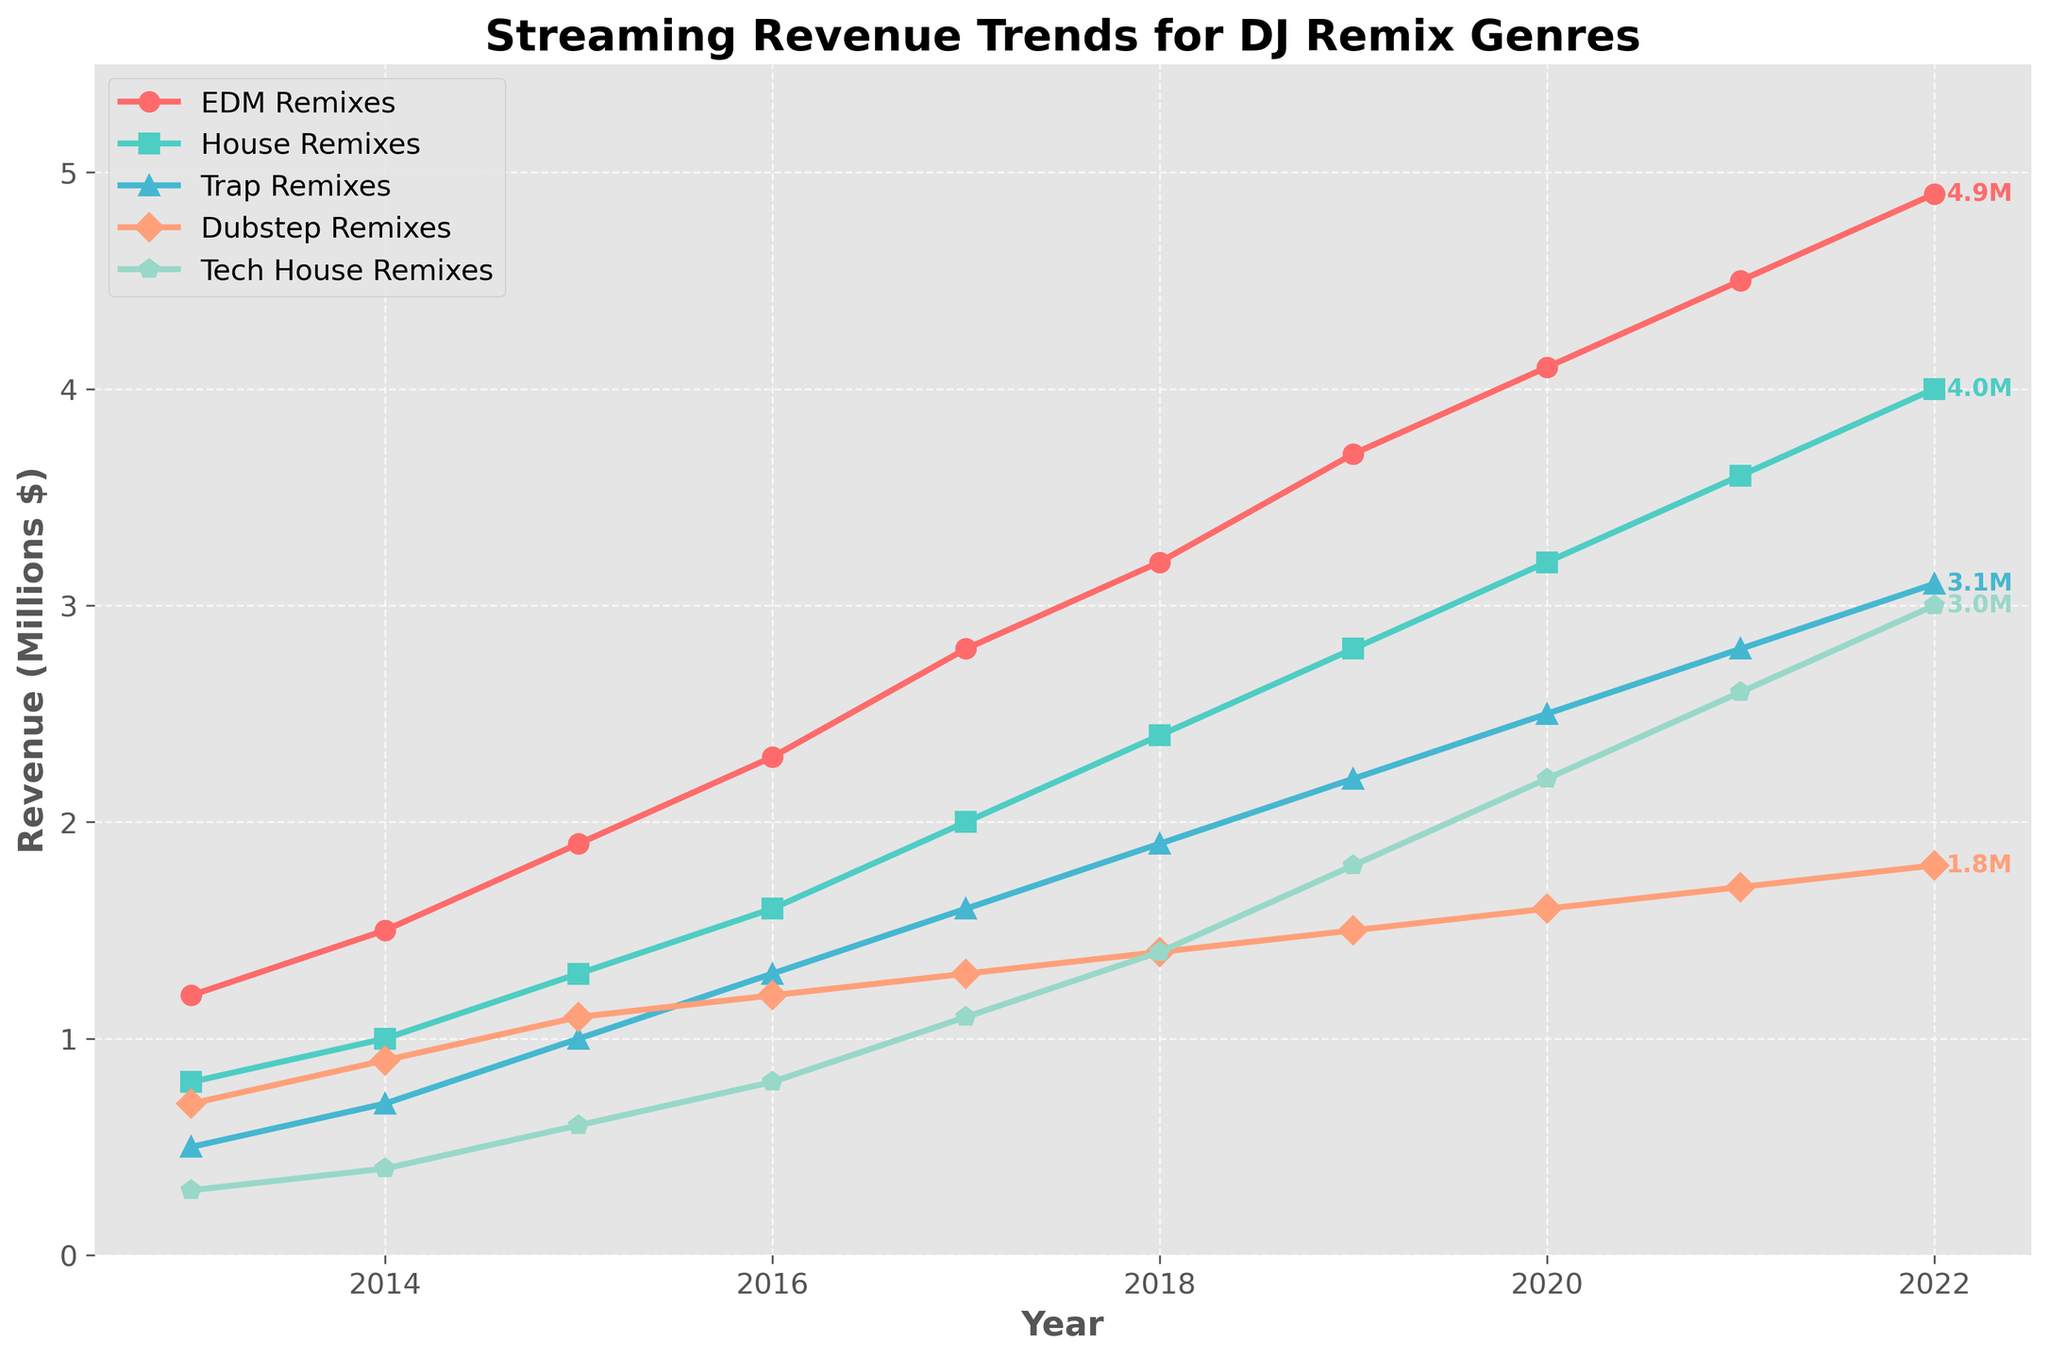What genres are included in the figure? The figure shows the streaming revenue trends for EDM Remixes, House Remixes, Trap Remixes, Dubstep Remixes, and Tech House Remixes.
Answer: EDM Remixes, House Remixes, Trap Remixes, Dubstep Remixes, Tech House Remixes Which remix genre had the highest streaming revenue in 2022? By looking at the endpoints of the lines for the year 2022, EDM Remixes had the highest value at 4.9 million dollars.
Answer: EDM Remixes How has the streaming revenue for House Remixes changed from 2013 to 2022? In 2013, the revenue for House Remixes was 0.8 million dollars. In 2022, it was 4.0 million dollars. So, the change is 4.0 - 0.8 = 3.2 million dollars.
Answer: Increased by 3.2 million dollars Which genre showed the most consistent growth over the decade? Comparing the trends across all genres, EDM Remixes show a steady and consistent upwards trajectory without significant dips.
Answer: EDM Remixes In which year did Dubstep Remixes experience the smallest revenue increase compared to the previous year? By examining the plot, between 2015 and 2016, Dubstep Remixes increased from 1.1 to 1.2 million dollars, which is the smallest year-to-year increase.
Answer: 2016 How much more revenue did Trap Remixes generate in 2020 compared to 2015? In 2015, Trap Remixes generated 1.0 million dollars, and in 2020, they generated 2.5 million dollars. Thus, the difference is 2.5 - 1.0 = 1.5 million dollars.
Answer: 1.5 million dollars What is the overall trend in streaming revenue for Tech House Remixes? The trend for Tech House Remixes shows a steady increase from 0.3 million dollars in 2013 to 3.0 million dollars in 2022.
Answer: Increasing Which genre had the slowest start but showed significant growth later? Tech House Remixes started the decade with the lowest revenue in 2013 (0.3 million dollars) but grew significantly to 3.0 million dollars by 2022.
Answer: Tech House Remixes 